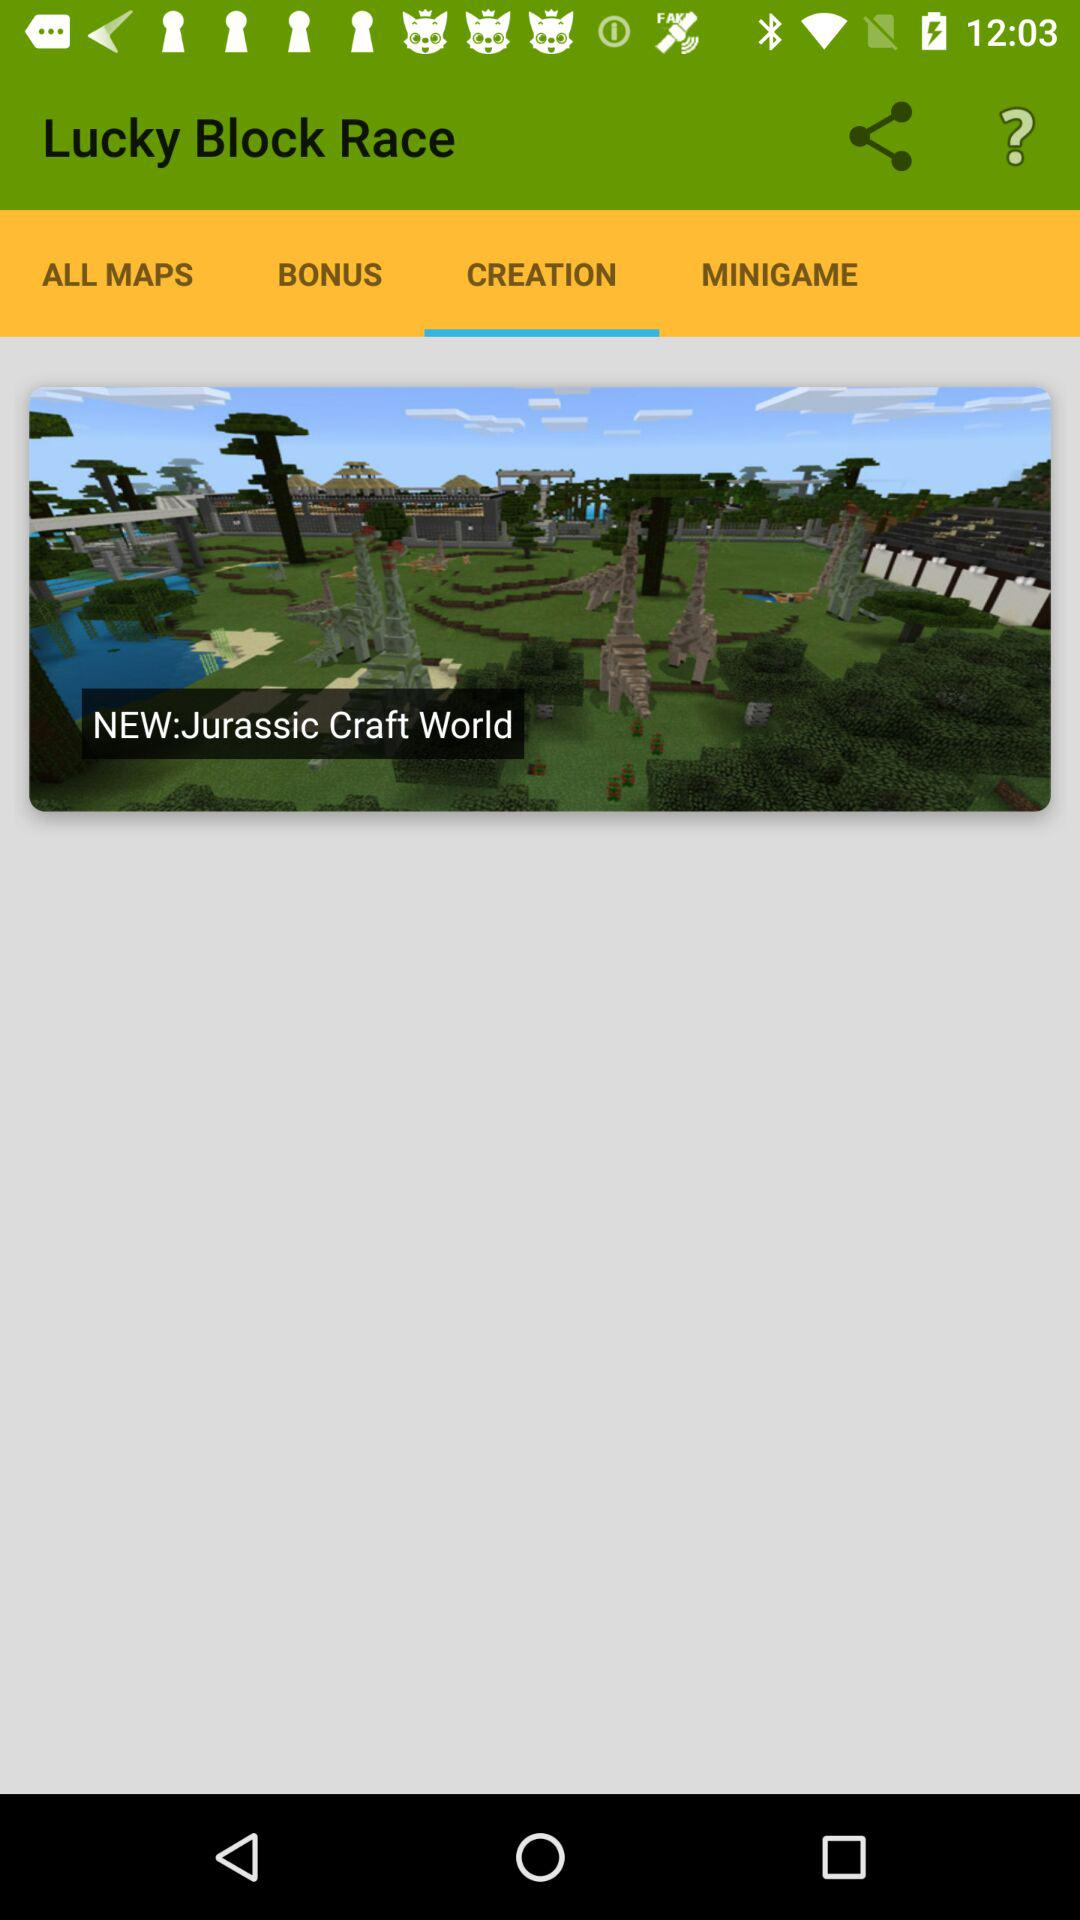What is the application name? The application name is "Lucky Block Race". 